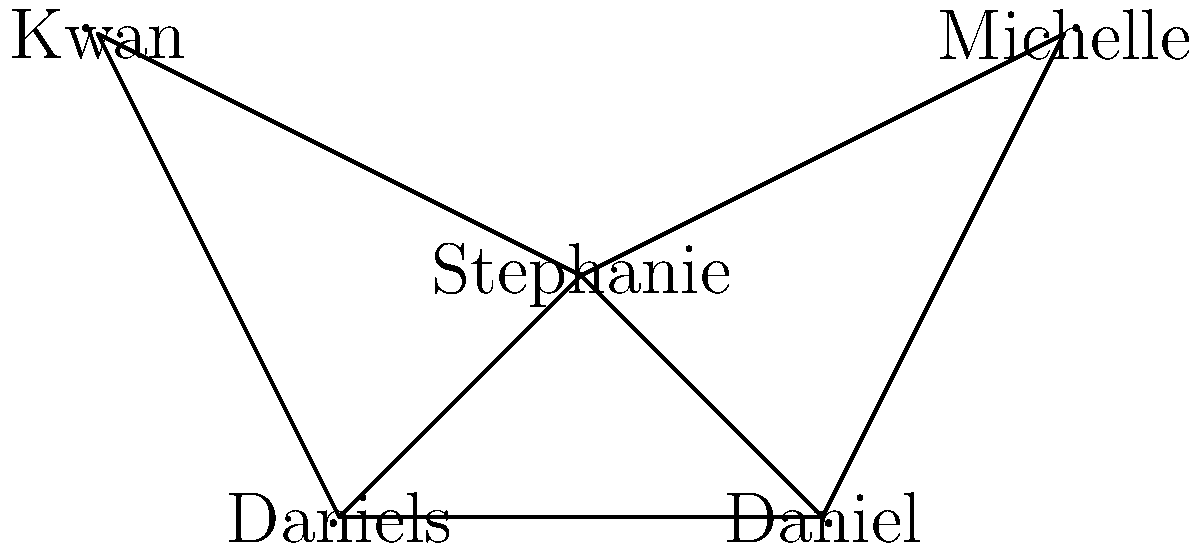In the collaboration graph of actors and directors shown above, which node has the highest degree centrality, and what is its value? To determine the node with the highest degree centrality and its value, we need to follow these steps:

1. Understand degree centrality: In graph theory, degree centrality is the number of direct connections (edges) a node has to other nodes.

2. Count the connections for each node:
   - Stephanie: 4 connections (to Michelle, Daniel, Daniels, and Kwan)
   - Michelle: 2 connections (to Stephanie and Daniel)
   - Daniel: 3 connections (to Stephanie, Michelle, and Daniels)
   - Daniels: 3 connections (to Stephanie, Daniel, and Kwan)
   - Kwan: 2 connections (to Stephanie and Daniels)

3. Identify the highest degree centrality:
   Stephanie has the highest number of connections with 4.

4. Calculate the degree centrality value:
   In a simple undirected graph, the degree centrality is often normalized by dividing by the maximum possible degree, which is $n-1$, where $n$ is the number of nodes.
   
   In this case, $n = 5$, so the maximum possible degree is $5-1 = 4$.
   
   Stephanie's normalized degree centrality = $\frac{4}{4} = 1$

Therefore, Stephanie has the highest degree centrality with a value of 1.
Answer: Stephanie, 1 